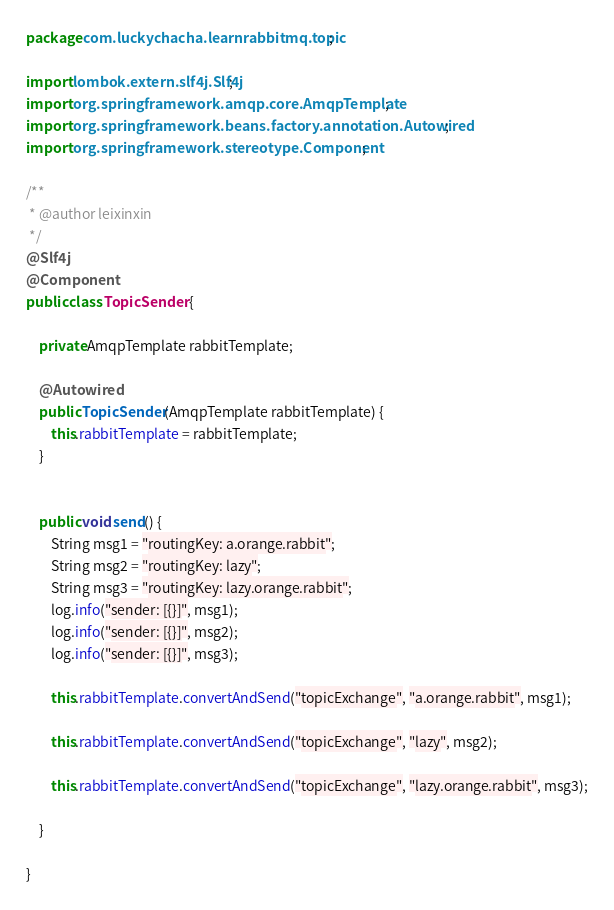Convert code to text. <code><loc_0><loc_0><loc_500><loc_500><_Java_>package com.luckychacha.learnrabbitmq.topic;

import lombok.extern.slf4j.Slf4j;
import org.springframework.amqp.core.AmqpTemplate;
import org.springframework.beans.factory.annotation.Autowired;
import org.springframework.stereotype.Component;

/**
 * @author leixinxin
 */
@Slf4j
@Component
public class TopicSender {

    private AmqpTemplate rabbitTemplate;

    @Autowired
    public TopicSender(AmqpTemplate rabbitTemplate) {
        this.rabbitTemplate = rabbitTemplate;
    }


    public void send() {
        String msg1 = "routingKey: a.orange.rabbit";
        String msg2 = "routingKey: lazy";
        String msg3 = "routingKey: lazy.orange.rabbit";
        log.info("sender: [{}]", msg1);
        log.info("sender: [{}]", msg2);
        log.info("sender: [{}]", msg3);

        this.rabbitTemplate.convertAndSend("topicExchange", "a.orange.rabbit", msg1);

        this.rabbitTemplate.convertAndSend("topicExchange", "lazy", msg2);

        this.rabbitTemplate.convertAndSend("topicExchange", "lazy.orange.rabbit", msg3);

    }

}
</code> 